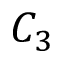<formula> <loc_0><loc_0><loc_500><loc_500>C _ { 3 }</formula> 